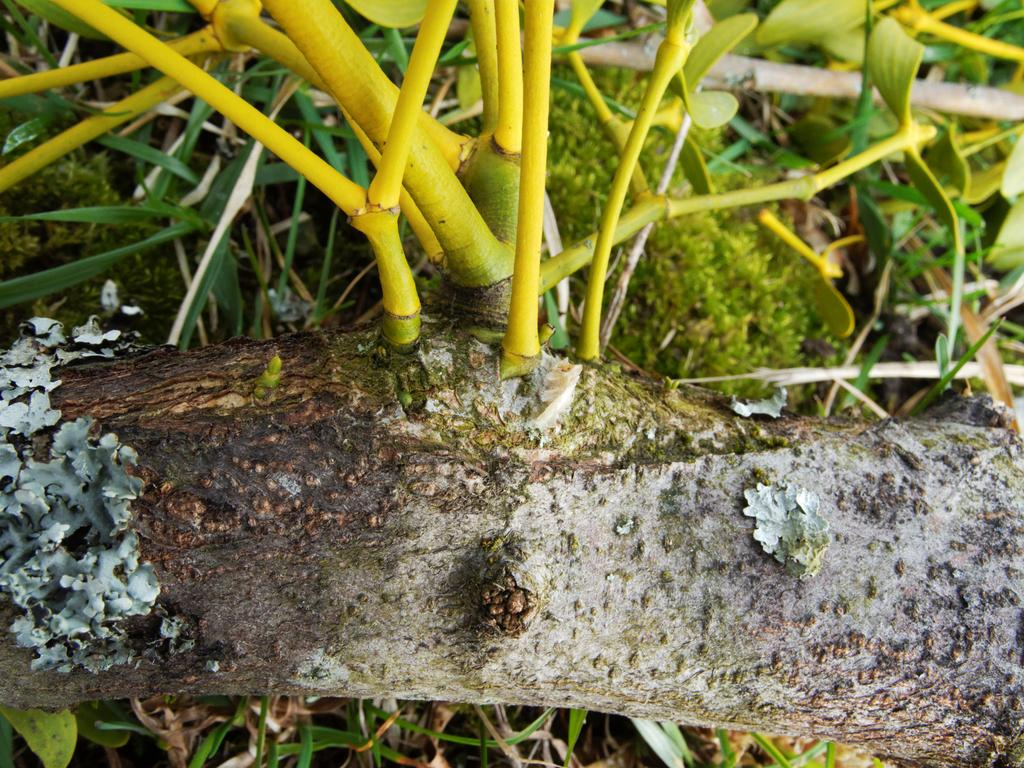What type of vegetation can be seen in the image? There is a tree with branches, plants, and bushes in the image. What is covering the surface in the image? There is grass on the surface in the image. How many boots are visible in the image? There are no boots present in the image. What type of plantation can be seen in the image? There is no plantation present in the image; it features a tree, plants, bushes, and grass. 